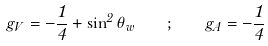Convert formula to latex. <formula><loc_0><loc_0><loc_500><loc_500>g _ { V } = - \frac { 1 } { 4 } + \sin ^ { 2 } \theta _ { w } \quad ; \quad g _ { A } = - \frac { 1 } { 4 }</formula> 